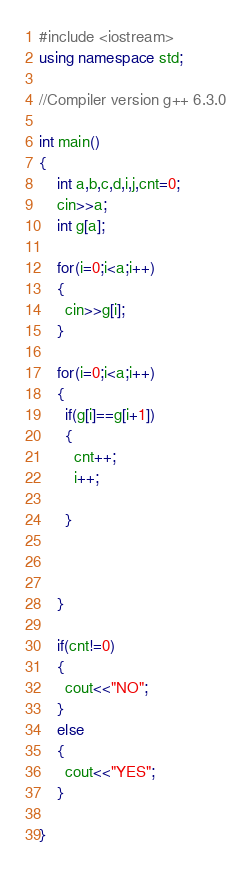<code> <loc_0><loc_0><loc_500><loc_500><_C++_>#include <iostream>
using namespace std;

//Compiler version g++ 6.3.0

int main()
{
    int a,b,c,d,i,j,cnt=0;
    cin>>a;
    int g[a];
    
    for(i=0;i<a;i++)
    {
      cin>>g[i];
    }
    
    for(i=0;i<a;i++)
    {
      if(g[i]==g[i+1])
      {
        cnt++;
        i++;
        
      }
      
    
     
    }
    
    if(cnt!=0)
    {
      cout<<"NO";
    }
    else
    {
      cout<<"YES";
    }
    
}</code> 